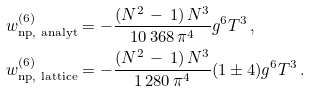<formula> <loc_0><loc_0><loc_500><loc_500>w _ { \text {np, analyt} } ^ { ( 6 ) } & = - \frac { ( N ^ { 2 } \, - \, 1 ) \, N ^ { 3 } } { 1 0 \, 3 6 8 \, \pi ^ { 4 } } g ^ { 6 } T ^ { 3 } \, , \\ w _ { \text {np, lattice} } ^ { ( 6 ) } & = - \frac { ( N ^ { 2 } \, - \, 1 ) \, N ^ { 3 } } { 1 \, 2 8 0 \, \pi ^ { 4 } } ( 1 \pm 4 ) g ^ { 6 } T ^ { 3 } \, .</formula> 